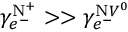<formula> <loc_0><loc_0><loc_500><loc_500>\gamma _ { e ^ { - } } ^ { N ^ { + } } > > \gamma _ { e ^ { - } } ^ { N V ^ { 0 } }</formula> 